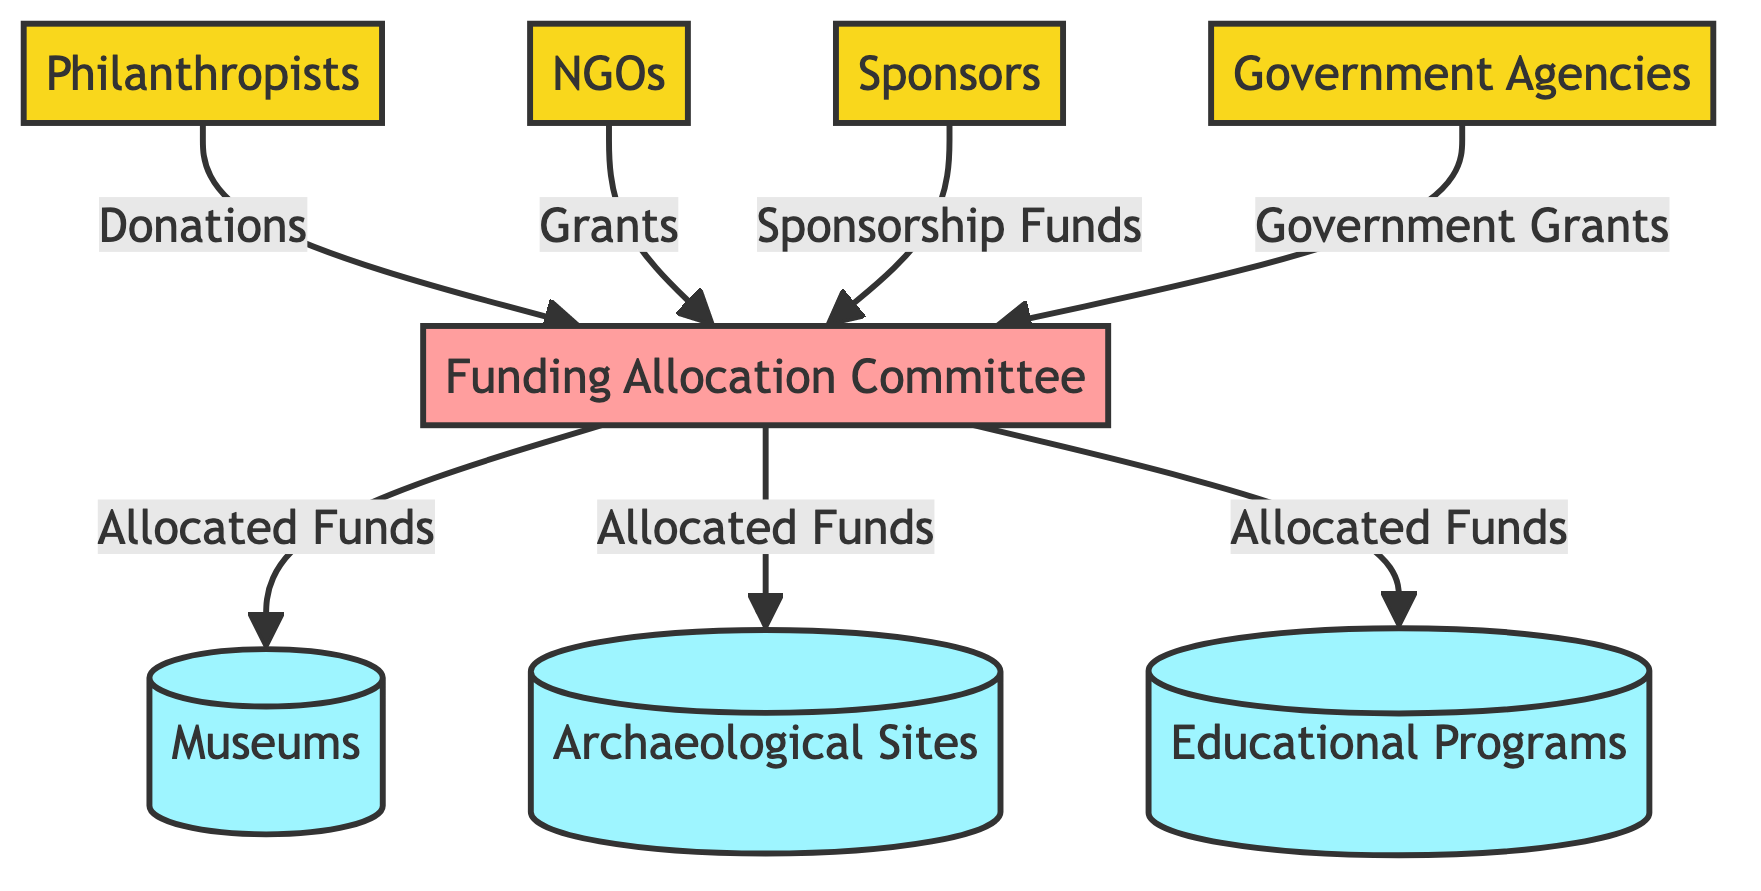What are the external entities involved in the funding process? The diagram indicates four external entities: Philanthropists, NGOs, Sponsors, and Government Agencies. These entities provide different kinds of funding to the Funding Allocation Committee.
Answer: Philanthropists, NGOs, Sponsors, Government Agencies How many data stores are represented in the diagram? The diagram illustrates three data stores that represent the types of projects receiving funding: Museums, Archaeological Sites, and Educational Programs.
Answer: Three What type of data do NGOs contribute to the Funding Allocation Committee? According to the diagram, NGOs contribute "Grants" to the Funding Allocation Committee, which plays a role in resource allocation for cultural heritage projects.
Answer: Grants Which process handles the allocation of funds to various cultural heritage projects? The Funding Allocation Committee is identified in the diagram as the process responsible for distributing funds to the data stores, ensuring resources are allocated effectively.
Answer: Funding Allocation Committee How many types of funding are received by the Funding Allocation Committee from external entities? The diagram shows that four types of funding are received by the Funding Allocation Committee: Donations from Philanthropists, Grants from NGOs, Sponsorship Funds from Sponsors, and Government Grants from Government Agencies.
Answer: Four Which data store receives funds allocated from the Funding Allocation Committee? The Funding Allocation Committee allocates funds to Museums, Archaeological Sites, and Educational Programs as shown in the flows from the committee to these entities in the diagram.
Answer: Museums, Archaeological Sites, Educational Programs What is the relationship between Philanthropists and the Funding Allocation Committee? Philanthropists provide "Donations" to the Funding Allocation Committee, which indicates a direct flow of funding from external entities to the process responsible for distribution.
Answer: Donations What type of diagram is being used to represent the funding flow? The current representation is a Data Flow Diagram (DFD), which visualizes the movement of data (funding) between entities, processes, and data stores involved in cultural heritage projects.
Answer: Data Flow Diagram 